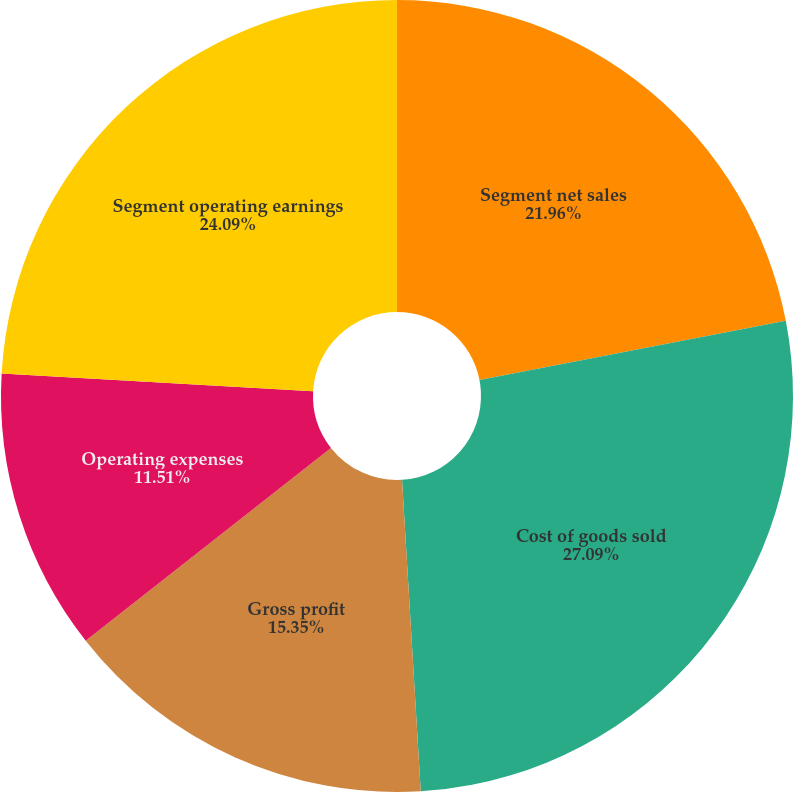Convert chart to OTSL. <chart><loc_0><loc_0><loc_500><loc_500><pie_chart><fcel>Segment net sales<fcel>Cost of goods sold<fcel>Gross profit<fcel>Operating expenses<fcel>Segment operating earnings<nl><fcel>21.96%<fcel>27.08%<fcel>15.35%<fcel>11.51%<fcel>24.09%<nl></chart> 